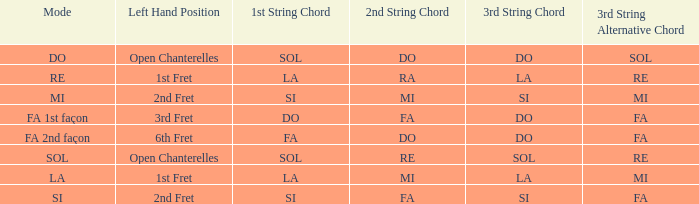What is the mode of the Depart de la main gauche of 1st case and a la or mi 3rd string? LA. 